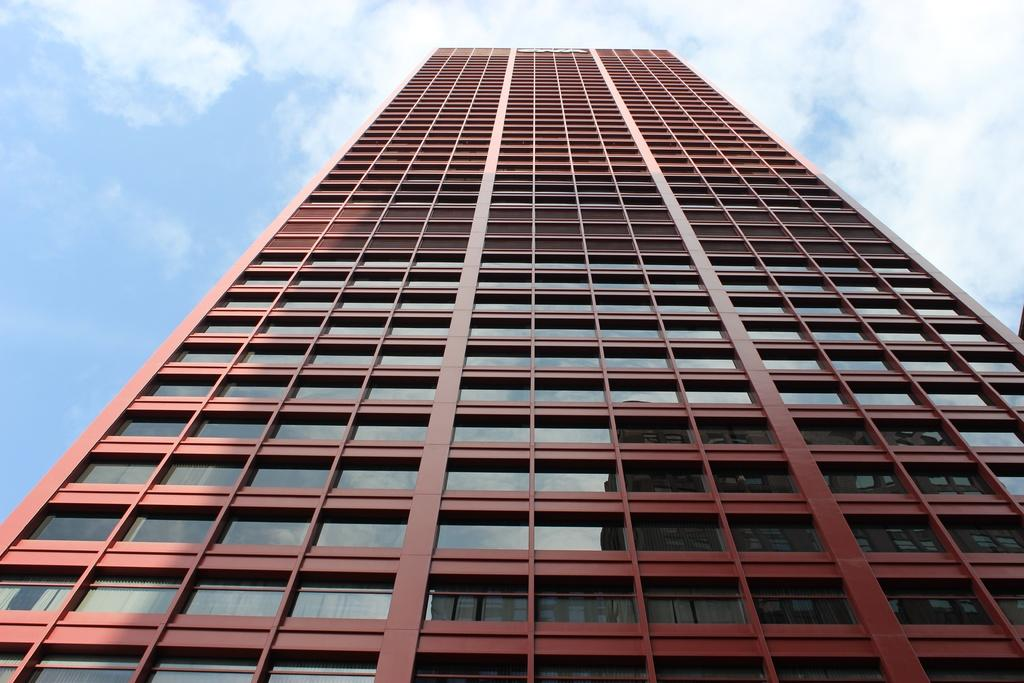Where was the picture taken? The picture was clicked outside the city. What is the main subject of the image? There is a building in the center of the image. What feature can be seen on the building? The building has windows. What can be seen in the background of the image? There is a sky visible in the background of the image. What is the weather like in the image? Clouds are present in the sky, suggesting a partly cloudy day. Can you see a giraffe standing next to the building in the image? No, there is no giraffe present in the image. How does the building show respect to the environment in the image? The image does not provide information about the building's environmental impact or the concept of respect. 